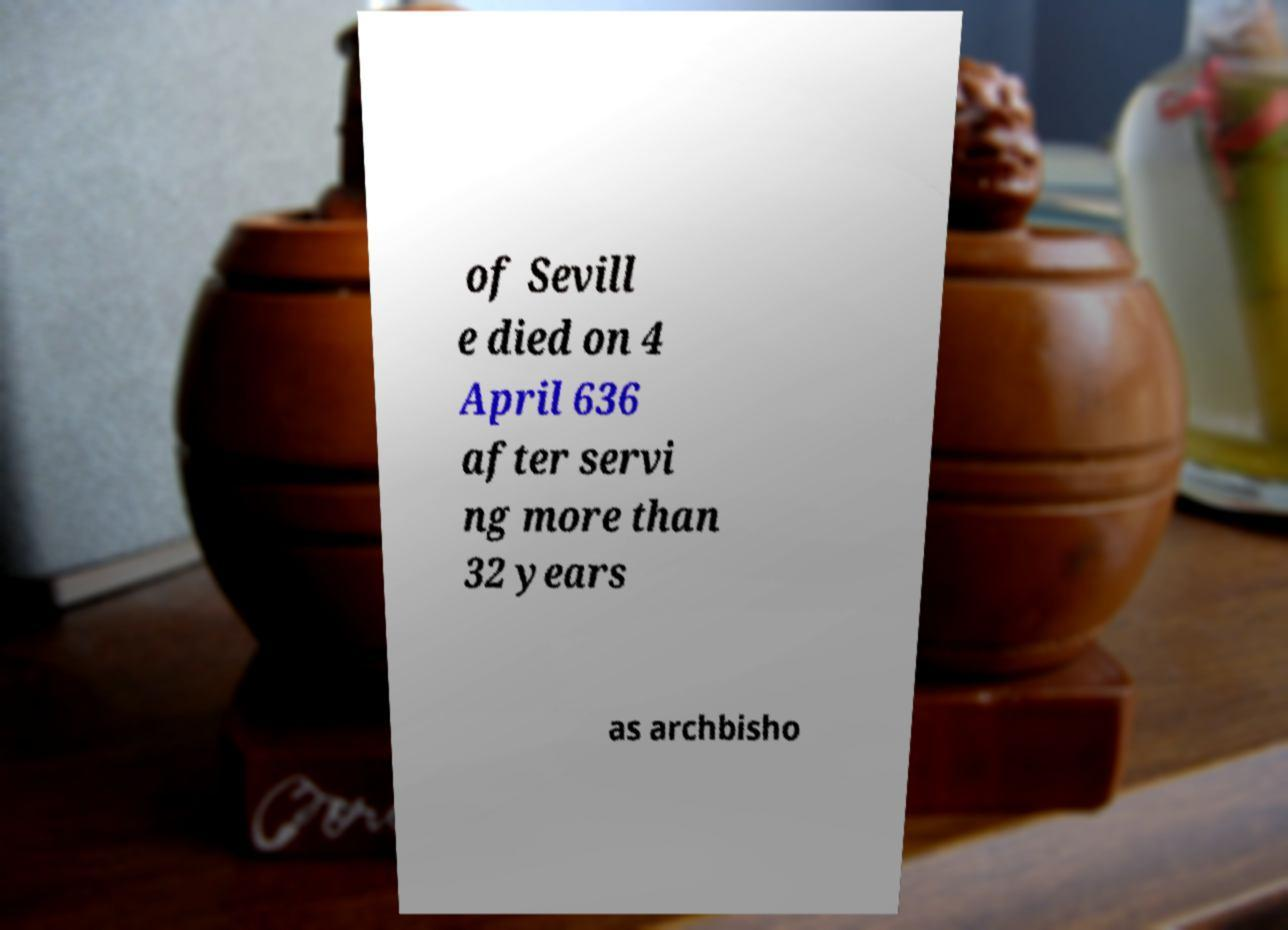Please read and relay the text visible in this image. What does it say? of Sevill e died on 4 April 636 after servi ng more than 32 years as archbisho 